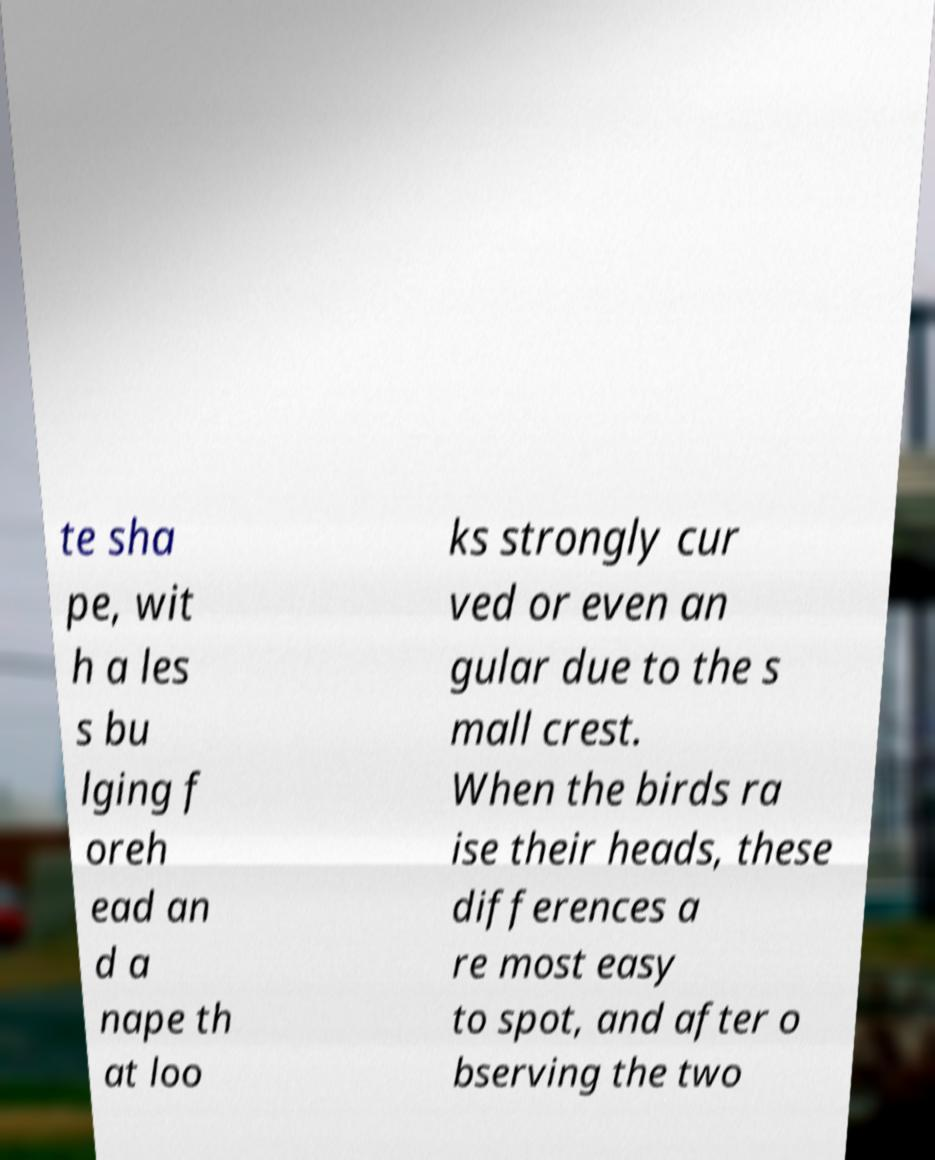For documentation purposes, I need the text within this image transcribed. Could you provide that? te sha pe, wit h a les s bu lging f oreh ead an d a nape th at loo ks strongly cur ved or even an gular due to the s mall crest. When the birds ra ise their heads, these differences a re most easy to spot, and after o bserving the two 